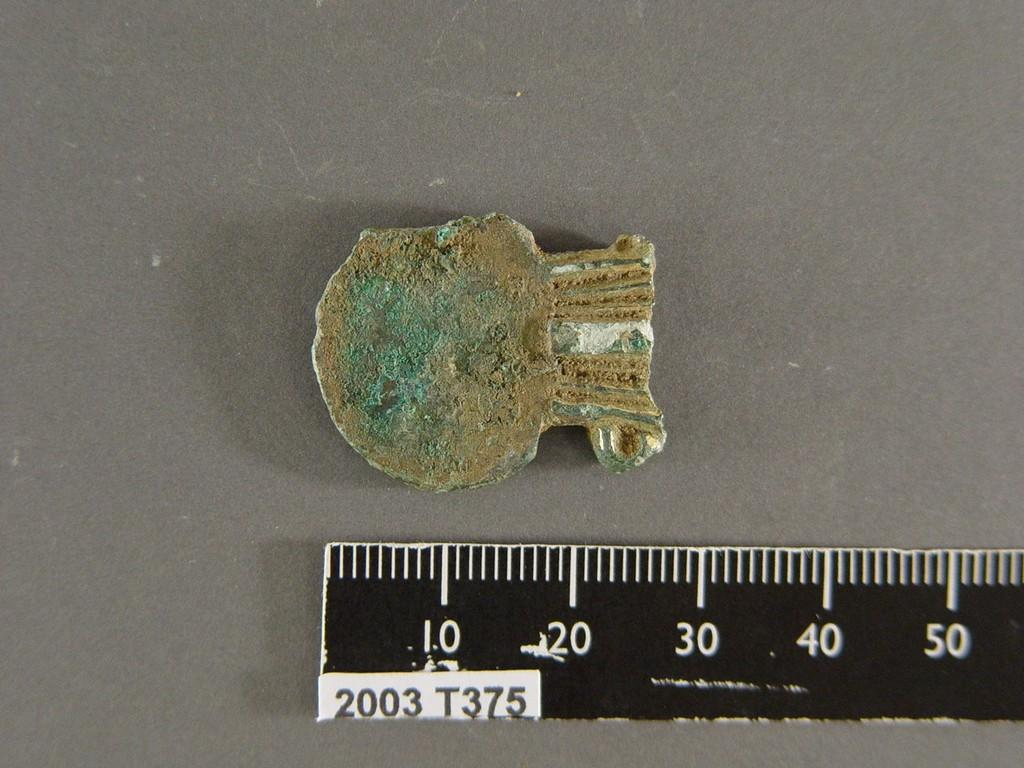<image>
Write a terse but informative summary of the picture. A ruler has a small sticker on it which contains the date 2003. 